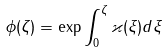<formula> <loc_0><loc_0><loc_500><loc_500>\phi ( \zeta ) = \exp \int _ { 0 } ^ { \zeta } \varkappa ( \xi ) d \xi</formula> 